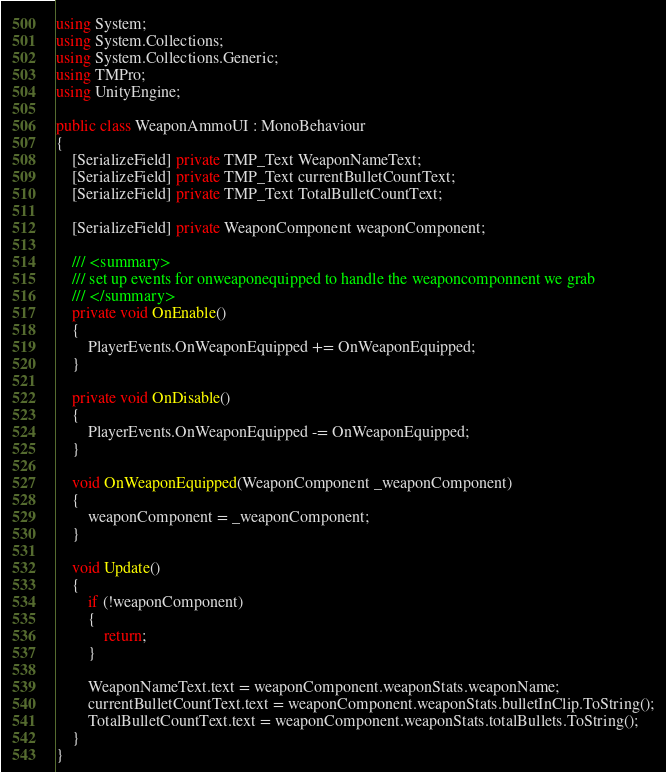Convert code to text. <code><loc_0><loc_0><loc_500><loc_500><_C#_>using System;
using System.Collections;
using System.Collections.Generic;
using TMPro;
using UnityEngine;

public class WeaponAmmoUI : MonoBehaviour
{
    [SerializeField] private TMP_Text WeaponNameText;
    [SerializeField] private TMP_Text currentBulletCountText;
    [SerializeField] private TMP_Text TotalBulletCountText;

    [SerializeField] private WeaponComponent weaponComponent;

    /// <summary>
    /// set up events for onweaponequipped to handle the weaponcomponnent we grab
    /// </summary>
    private void OnEnable()
    {
        PlayerEvents.OnWeaponEquipped += OnWeaponEquipped;
    }

    private void OnDisable()
    {
        PlayerEvents.OnWeaponEquipped -= OnWeaponEquipped;
    }

    void OnWeaponEquipped(WeaponComponent _weaponComponent)
    {
        weaponComponent = _weaponComponent;
    }

    void Update()
    {
        if (!weaponComponent)
        {
            return;
        }

        WeaponNameText.text = weaponComponent.weaponStats.weaponName;
        currentBulletCountText.text = weaponComponent.weaponStats.bulletInClip.ToString();
        TotalBulletCountText.text = weaponComponent.weaponStats.totalBullets.ToString();
    }
}
</code> 